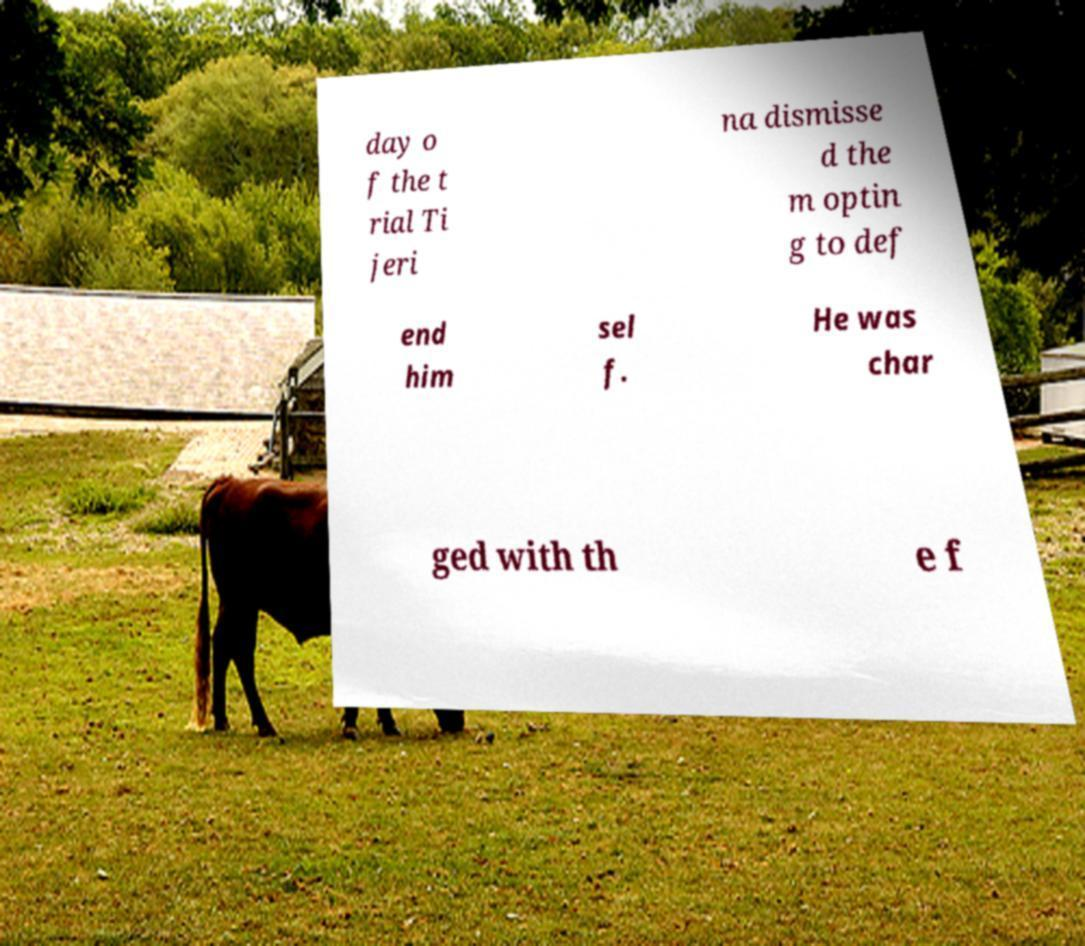I need the written content from this picture converted into text. Can you do that? day o f the t rial Ti jeri na dismisse d the m optin g to def end him sel f. He was char ged with th e f 